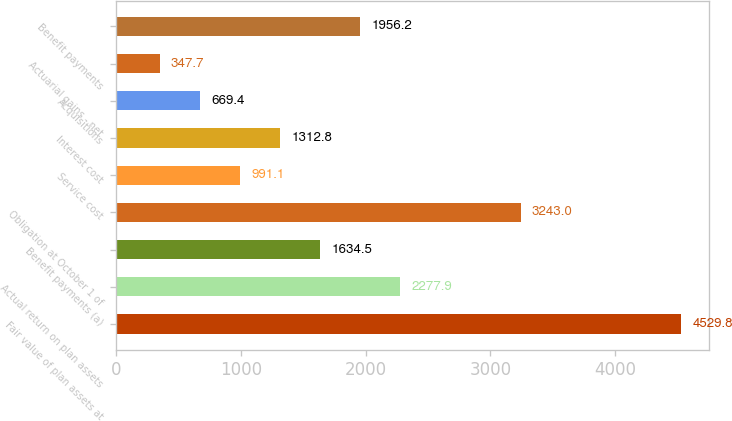Convert chart. <chart><loc_0><loc_0><loc_500><loc_500><bar_chart><fcel>Fair value of plan assets at<fcel>Actual return on plan assets<fcel>Benefit payments (a)<fcel>Obligation at October 1 of<fcel>Service cost<fcel>Interest cost<fcel>Acquisitions<fcel>Actuarial gains - net<fcel>Benefit payments<nl><fcel>4529.8<fcel>2277.9<fcel>1634.5<fcel>3243<fcel>991.1<fcel>1312.8<fcel>669.4<fcel>347.7<fcel>1956.2<nl></chart> 